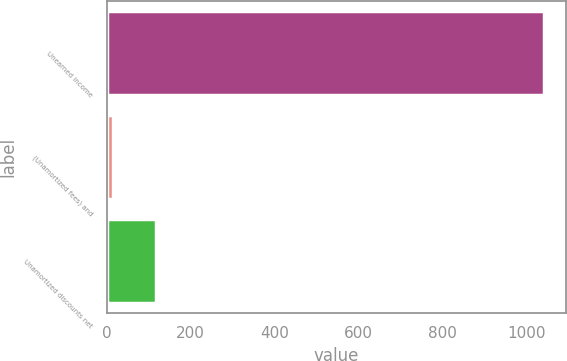Convert chart. <chart><loc_0><loc_0><loc_500><loc_500><bar_chart><fcel>Unearned income<fcel>(Unamortized fees) and<fcel>Unamortized discounts net<nl><fcel>1042<fcel>14<fcel>116.8<nl></chart> 